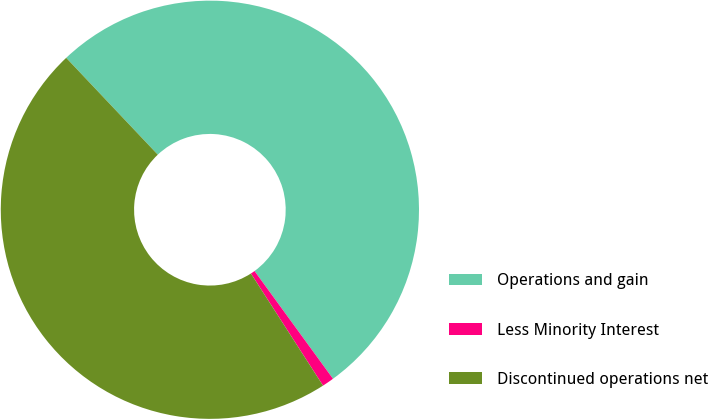Convert chart to OTSL. <chart><loc_0><loc_0><loc_500><loc_500><pie_chart><fcel>Operations and gain<fcel>Less Minority Interest<fcel>Discontinued operations net<nl><fcel>52.04%<fcel>0.92%<fcel>47.04%<nl></chart> 